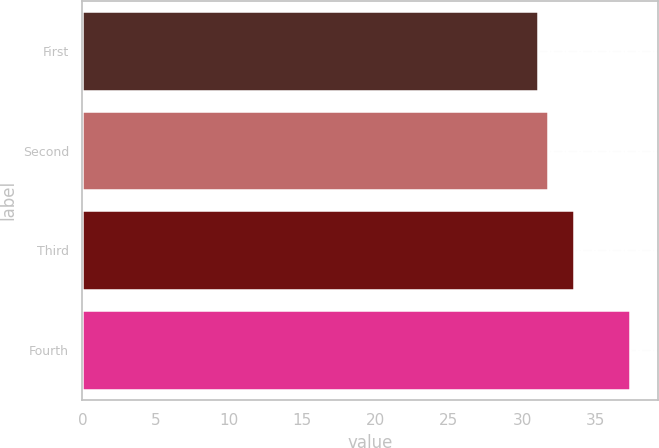Convert chart. <chart><loc_0><loc_0><loc_500><loc_500><bar_chart><fcel>First<fcel>Second<fcel>Third<fcel>Fourth<nl><fcel>31.08<fcel>31.74<fcel>33.55<fcel>37.38<nl></chart> 